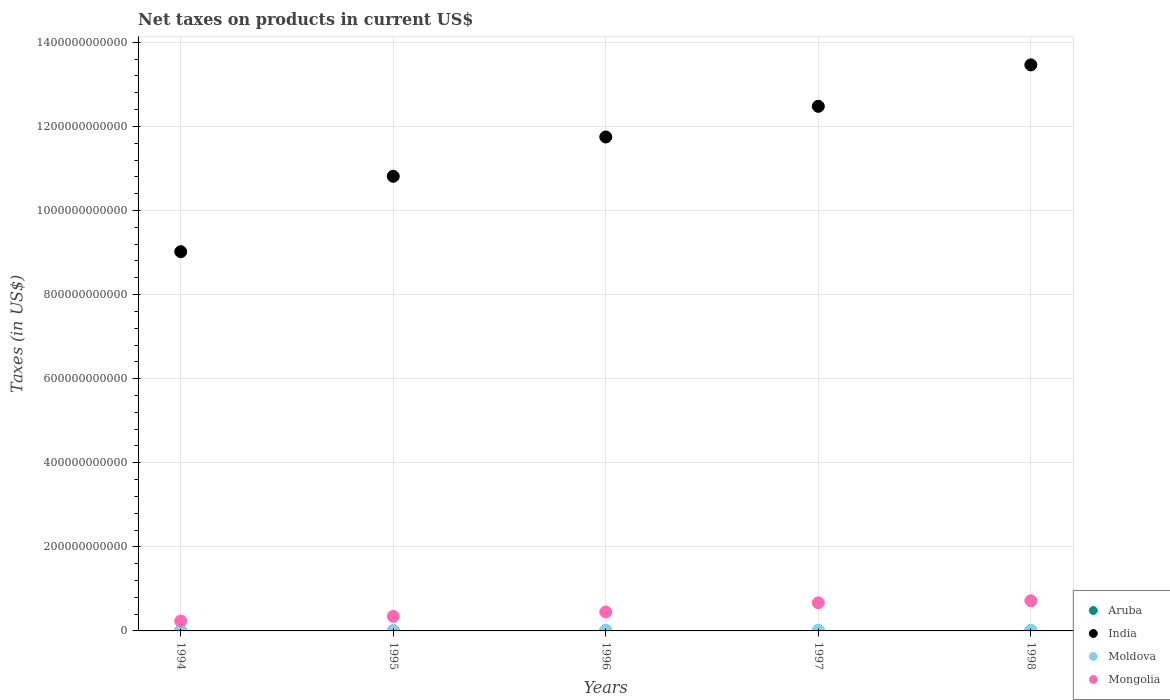How many different coloured dotlines are there?
Your answer should be compact. 4. What is the net taxes on products in Moldova in 1994?
Provide a short and direct response. 3.12e+08. Across all years, what is the maximum net taxes on products in Moldova?
Make the answer very short. 1.40e+09. Across all years, what is the minimum net taxes on products in Moldova?
Provide a short and direct response. 3.12e+08. In which year was the net taxes on products in Moldova maximum?
Provide a short and direct response. 1998. In which year was the net taxes on products in Aruba minimum?
Give a very brief answer. 1994. What is the total net taxes on products in Aruba in the graph?
Offer a very short reply. 1.09e+09. What is the difference between the net taxes on products in India in 1995 and that in 1997?
Provide a succinct answer. -1.66e+11. What is the difference between the net taxes on products in Aruba in 1998 and the net taxes on products in Mongolia in 1995?
Your response must be concise. -3.43e+1. What is the average net taxes on products in Aruba per year?
Give a very brief answer. 2.18e+08. In the year 1996, what is the difference between the net taxes on products in Moldova and net taxes on products in India?
Offer a terse response. -1.17e+12. What is the ratio of the net taxes on products in Aruba in 1996 to that in 1998?
Your answer should be very brief. 0.93. Is the net taxes on products in India in 1994 less than that in 1996?
Ensure brevity in your answer.  Yes. What is the difference between the highest and the second highest net taxes on products in Moldova?
Your answer should be compact. 1.51e+08. What is the difference between the highest and the lowest net taxes on products in Mongolia?
Offer a terse response. 4.82e+1. In how many years, is the net taxes on products in Moldova greater than the average net taxes on products in Moldova taken over all years?
Offer a very short reply. 3. Is it the case that in every year, the sum of the net taxes on products in Mongolia and net taxes on products in India  is greater than the net taxes on products in Moldova?
Provide a short and direct response. Yes. How many dotlines are there?
Give a very brief answer. 4. What is the difference between two consecutive major ticks on the Y-axis?
Ensure brevity in your answer.  2.00e+11. Where does the legend appear in the graph?
Keep it short and to the point. Bottom right. How many legend labels are there?
Keep it short and to the point. 4. What is the title of the graph?
Keep it short and to the point. Net taxes on products in current US$. What is the label or title of the Y-axis?
Keep it short and to the point. Taxes (in US$). What is the Taxes (in US$) in Aruba in 1994?
Make the answer very short. 1.95e+08. What is the Taxes (in US$) of India in 1994?
Offer a terse response. 9.02e+11. What is the Taxes (in US$) of Moldova in 1994?
Provide a short and direct response. 3.12e+08. What is the Taxes (in US$) of Mongolia in 1994?
Your answer should be very brief. 2.35e+1. What is the Taxes (in US$) of Aruba in 1995?
Offer a very short reply. 2.09e+08. What is the Taxes (in US$) of India in 1995?
Give a very brief answer. 1.08e+12. What is the Taxes (in US$) in Moldova in 1995?
Offer a very short reply. 7.36e+08. What is the Taxes (in US$) in Mongolia in 1995?
Keep it short and to the point. 3.45e+1. What is the Taxes (in US$) of Aruba in 1996?
Keep it short and to the point. 2.21e+08. What is the Taxes (in US$) of India in 1996?
Your response must be concise. 1.17e+12. What is the Taxes (in US$) of Moldova in 1996?
Your answer should be compact. 9.72e+08. What is the Taxes (in US$) in Mongolia in 1996?
Provide a succinct answer. 4.51e+1. What is the Taxes (in US$) of Aruba in 1997?
Make the answer very short. 2.29e+08. What is the Taxes (in US$) in India in 1997?
Provide a succinct answer. 1.25e+12. What is the Taxes (in US$) in Moldova in 1997?
Provide a succinct answer. 1.25e+09. What is the Taxes (in US$) in Mongolia in 1997?
Make the answer very short. 6.69e+1. What is the Taxes (in US$) in Aruba in 1998?
Your response must be concise. 2.38e+08. What is the Taxes (in US$) of India in 1998?
Your answer should be very brief. 1.35e+12. What is the Taxes (in US$) in Moldova in 1998?
Offer a very short reply. 1.40e+09. What is the Taxes (in US$) in Mongolia in 1998?
Provide a short and direct response. 7.17e+1. Across all years, what is the maximum Taxes (in US$) in Aruba?
Your response must be concise. 2.38e+08. Across all years, what is the maximum Taxes (in US$) of India?
Give a very brief answer. 1.35e+12. Across all years, what is the maximum Taxes (in US$) in Moldova?
Offer a very short reply. 1.40e+09. Across all years, what is the maximum Taxes (in US$) of Mongolia?
Make the answer very short. 7.17e+1. Across all years, what is the minimum Taxes (in US$) of Aruba?
Make the answer very short. 1.95e+08. Across all years, what is the minimum Taxes (in US$) of India?
Give a very brief answer. 9.02e+11. Across all years, what is the minimum Taxes (in US$) of Moldova?
Give a very brief answer. 3.12e+08. Across all years, what is the minimum Taxes (in US$) of Mongolia?
Offer a terse response. 2.35e+1. What is the total Taxes (in US$) in Aruba in the graph?
Ensure brevity in your answer.  1.09e+09. What is the total Taxes (in US$) of India in the graph?
Provide a short and direct response. 5.75e+12. What is the total Taxes (in US$) in Moldova in the graph?
Ensure brevity in your answer.  4.67e+09. What is the total Taxes (in US$) in Mongolia in the graph?
Provide a succinct answer. 2.42e+11. What is the difference between the Taxes (in US$) of Aruba in 1994 and that in 1995?
Give a very brief answer. -1.40e+07. What is the difference between the Taxes (in US$) in India in 1994 and that in 1995?
Your response must be concise. -1.79e+11. What is the difference between the Taxes (in US$) of Moldova in 1994 and that in 1995?
Offer a very short reply. -4.24e+08. What is the difference between the Taxes (in US$) of Mongolia in 1994 and that in 1995?
Your answer should be compact. -1.10e+1. What is the difference between the Taxes (in US$) of Aruba in 1994 and that in 1996?
Offer a very short reply. -2.60e+07. What is the difference between the Taxes (in US$) in India in 1994 and that in 1996?
Provide a short and direct response. -2.73e+11. What is the difference between the Taxes (in US$) in Moldova in 1994 and that in 1996?
Make the answer very short. -6.60e+08. What is the difference between the Taxes (in US$) in Mongolia in 1994 and that in 1996?
Your answer should be compact. -2.16e+1. What is the difference between the Taxes (in US$) of Aruba in 1994 and that in 1997?
Give a very brief answer. -3.40e+07. What is the difference between the Taxes (in US$) of India in 1994 and that in 1997?
Give a very brief answer. -3.46e+11. What is the difference between the Taxes (in US$) in Moldova in 1994 and that in 1997?
Keep it short and to the point. -9.41e+08. What is the difference between the Taxes (in US$) in Mongolia in 1994 and that in 1997?
Your response must be concise. -4.34e+1. What is the difference between the Taxes (in US$) in Aruba in 1994 and that in 1998?
Offer a terse response. -4.35e+07. What is the difference between the Taxes (in US$) of India in 1994 and that in 1998?
Your answer should be compact. -4.44e+11. What is the difference between the Taxes (in US$) of Moldova in 1994 and that in 1998?
Offer a terse response. -1.09e+09. What is the difference between the Taxes (in US$) of Mongolia in 1994 and that in 1998?
Your answer should be very brief. -4.82e+1. What is the difference between the Taxes (in US$) of Aruba in 1995 and that in 1996?
Offer a very short reply. -1.20e+07. What is the difference between the Taxes (in US$) of India in 1995 and that in 1996?
Ensure brevity in your answer.  -9.35e+1. What is the difference between the Taxes (in US$) in Moldova in 1995 and that in 1996?
Give a very brief answer. -2.36e+08. What is the difference between the Taxes (in US$) in Mongolia in 1995 and that in 1996?
Give a very brief answer. -1.06e+1. What is the difference between the Taxes (in US$) in Aruba in 1995 and that in 1997?
Offer a terse response. -2.00e+07. What is the difference between the Taxes (in US$) in India in 1995 and that in 1997?
Your answer should be very brief. -1.66e+11. What is the difference between the Taxes (in US$) in Moldova in 1995 and that in 1997?
Your answer should be compact. -5.17e+08. What is the difference between the Taxes (in US$) in Mongolia in 1995 and that in 1997?
Give a very brief answer. -3.24e+1. What is the difference between the Taxes (in US$) in Aruba in 1995 and that in 1998?
Give a very brief answer. -2.95e+07. What is the difference between the Taxes (in US$) in India in 1995 and that in 1998?
Give a very brief answer. -2.65e+11. What is the difference between the Taxes (in US$) of Moldova in 1995 and that in 1998?
Your answer should be compact. -6.68e+08. What is the difference between the Taxes (in US$) in Mongolia in 1995 and that in 1998?
Keep it short and to the point. -3.72e+1. What is the difference between the Taxes (in US$) of Aruba in 1996 and that in 1997?
Give a very brief answer. -8.00e+06. What is the difference between the Taxes (in US$) of India in 1996 and that in 1997?
Ensure brevity in your answer.  -7.29e+1. What is the difference between the Taxes (in US$) of Moldova in 1996 and that in 1997?
Make the answer very short. -2.81e+08. What is the difference between the Taxes (in US$) in Mongolia in 1996 and that in 1997?
Offer a very short reply. -2.18e+1. What is the difference between the Taxes (in US$) of Aruba in 1996 and that in 1998?
Your answer should be compact. -1.75e+07. What is the difference between the Taxes (in US$) of India in 1996 and that in 1998?
Provide a short and direct response. -1.72e+11. What is the difference between the Taxes (in US$) of Moldova in 1996 and that in 1998?
Keep it short and to the point. -4.32e+08. What is the difference between the Taxes (in US$) of Mongolia in 1996 and that in 1998?
Your answer should be very brief. -2.66e+1. What is the difference between the Taxes (in US$) of Aruba in 1997 and that in 1998?
Give a very brief answer. -9.46e+06. What is the difference between the Taxes (in US$) of India in 1997 and that in 1998?
Keep it short and to the point. -9.86e+1. What is the difference between the Taxes (in US$) in Moldova in 1997 and that in 1998?
Make the answer very short. -1.51e+08. What is the difference between the Taxes (in US$) in Mongolia in 1997 and that in 1998?
Keep it short and to the point. -4.81e+09. What is the difference between the Taxes (in US$) in Aruba in 1994 and the Taxes (in US$) in India in 1995?
Give a very brief answer. -1.08e+12. What is the difference between the Taxes (in US$) of Aruba in 1994 and the Taxes (in US$) of Moldova in 1995?
Keep it short and to the point. -5.41e+08. What is the difference between the Taxes (in US$) in Aruba in 1994 and the Taxes (in US$) in Mongolia in 1995?
Your answer should be compact. -3.43e+1. What is the difference between the Taxes (in US$) of India in 1994 and the Taxes (in US$) of Moldova in 1995?
Make the answer very short. 9.01e+11. What is the difference between the Taxes (in US$) of India in 1994 and the Taxes (in US$) of Mongolia in 1995?
Your answer should be compact. 8.68e+11. What is the difference between the Taxes (in US$) in Moldova in 1994 and the Taxes (in US$) in Mongolia in 1995?
Give a very brief answer. -3.42e+1. What is the difference between the Taxes (in US$) of Aruba in 1994 and the Taxes (in US$) of India in 1996?
Your response must be concise. -1.17e+12. What is the difference between the Taxes (in US$) of Aruba in 1994 and the Taxes (in US$) of Moldova in 1996?
Give a very brief answer. -7.77e+08. What is the difference between the Taxes (in US$) of Aruba in 1994 and the Taxes (in US$) of Mongolia in 1996?
Provide a succinct answer. -4.49e+1. What is the difference between the Taxes (in US$) of India in 1994 and the Taxes (in US$) of Moldova in 1996?
Offer a terse response. 9.01e+11. What is the difference between the Taxes (in US$) in India in 1994 and the Taxes (in US$) in Mongolia in 1996?
Give a very brief answer. 8.57e+11. What is the difference between the Taxes (in US$) of Moldova in 1994 and the Taxes (in US$) of Mongolia in 1996?
Your answer should be very brief. -4.48e+1. What is the difference between the Taxes (in US$) of Aruba in 1994 and the Taxes (in US$) of India in 1997?
Ensure brevity in your answer.  -1.25e+12. What is the difference between the Taxes (in US$) in Aruba in 1994 and the Taxes (in US$) in Moldova in 1997?
Keep it short and to the point. -1.06e+09. What is the difference between the Taxes (in US$) in Aruba in 1994 and the Taxes (in US$) in Mongolia in 1997?
Give a very brief answer. -6.67e+1. What is the difference between the Taxes (in US$) of India in 1994 and the Taxes (in US$) of Moldova in 1997?
Ensure brevity in your answer.  9.01e+11. What is the difference between the Taxes (in US$) of India in 1994 and the Taxes (in US$) of Mongolia in 1997?
Make the answer very short. 8.35e+11. What is the difference between the Taxes (in US$) in Moldova in 1994 and the Taxes (in US$) in Mongolia in 1997?
Give a very brief answer. -6.66e+1. What is the difference between the Taxes (in US$) in Aruba in 1994 and the Taxes (in US$) in India in 1998?
Ensure brevity in your answer.  -1.35e+12. What is the difference between the Taxes (in US$) of Aruba in 1994 and the Taxes (in US$) of Moldova in 1998?
Give a very brief answer. -1.21e+09. What is the difference between the Taxes (in US$) in Aruba in 1994 and the Taxes (in US$) in Mongolia in 1998?
Provide a succinct answer. -7.15e+1. What is the difference between the Taxes (in US$) in India in 1994 and the Taxes (in US$) in Moldova in 1998?
Your answer should be very brief. 9.01e+11. What is the difference between the Taxes (in US$) of India in 1994 and the Taxes (in US$) of Mongolia in 1998?
Keep it short and to the point. 8.30e+11. What is the difference between the Taxes (in US$) in Moldova in 1994 and the Taxes (in US$) in Mongolia in 1998?
Ensure brevity in your answer.  -7.14e+1. What is the difference between the Taxes (in US$) of Aruba in 1995 and the Taxes (in US$) of India in 1996?
Give a very brief answer. -1.17e+12. What is the difference between the Taxes (in US$) of Aruba in 1995 and the Taxes (in US$) of Moldova in 1996?
Offer a very short reply. -7.63e+08. What is the difference between the Taxes (in US$) in Aruba in 1995 and the Taxes (in US$) in Mongolia in 1996?
Your answer should be compact. -4.49e+1. What is the difference between the Taxes (in US$) of India in 1995 and the Taxes (in US$) of Moldova in 1996?
Your response must be concise. 1.08e+12. What is the difference between the Taxes (in US$) in India in 1995 and the Taxes (in US$) in Mongolia in 1996?
Offer a terse response. 1.04e+12. What is the difference between the Taxes (in US$) in Moldova in 1995 and the Taxes (in US$) in Mongolia in 1996?
Provide a succinct answer. -4.44e+1. What is the difference between the Taxes (in US$) in Aruba in 1995 and the Taxes (in US$) in India in 1997?
Ensure brevity in your answer.  -1.25e+12. What is the difference between the Taxes (in US$) of Aruba in 1995 and the Taxes (in US$) of Moldova in 1997?
Offer a terse response. -1.04e+09. What is the difference between the Taxes (in US$) in Aruba in 1995 and the Taxes (in US$) in Mongolia in 1997?
Offer a very short reply. -6.67e+1. What is the difference between the Taxes (in US$) in India in 1995 and the Taxes (in US$) in Moldova in 1997?
Ensure brevity in your answer.  1.08e+12. What is the difference between the Taxes (in US$) in India in 1995 and the Taxes (in US$) in Mongolia in 1997?
Make the answer very short. 1.01e+12. What is the difference between the Taxes (in US$) of Moldova in 1995 and the Taxes (in US$) of Mongolia in 1997?
Keep it short and to the point. -6.62e+1. What is the difference between the Taxes (in US$) of Aruba in 1995 and the Taxes (in US$) of India in 1998?
Offer a very short reply. -1.35e+12. What is the difference between the Taxes (in US$) in Aruba in 1995 and the Taxes (in US$) in Moldova in 1998?
Offer a terse response. -1.19e+09. What is the difference between the Taxes (in US$) in Aruba in 1995 and the Taxes (in US$) in Mongolia in 1998?
Your answer should be compact. -7.15e+1. What is the difference between the Taxes (in US$) of India in 1995 and the Taxes (in US$) of Moldova in 1998?
Give a very brief answer. 1.08e+12. What is the difference between the Taxes (in US$) of India in 1995 and the Taxes (in US$) of Mongolia in 1998?
Offer a very short reply. 1.01e+12. What is the difference between the Taxes (in US$) in Moldova in 1995 and the Taxes (in US$) in Mongolia in 1998?
Your answer should be compact. -7.10e+1. What is the difference between the Taxes (in US$) in Aruba in 1996 and the Taxes (in US$) in India in 1997?
Your answer should be compact. -1.25e+12. What is the difference between the Taxes (in US$) in Aruba in 1996 and the Taxes (in US$) in Moldova in 1997?
Your answer should be very brief. -1.03e+09. What is the difference between the Taxes (in US$) in Aruba in 1996 and the Taxes (in US$) in Mongolia in 1997?
Provide a short and direct response. -6.67e+1. What is the difference between the Taxes (in US$) in India in 1996 and the Taxes (in US$) in Moldova in 1997?
Offer a very short reply. 1.17e+12. What is the difference between the Taxes (in US$) in India in 1996 and the Taxes (in US$) in Mongolia in 1997?
Ensure brevity in your answer.  1.11e+12. What is the difference between the Taxes (in US$) of Moldova in 1996 and the Taxes (in US$) of Mongolia in 1997?
Give a very brief answer. -6.59e+1. What is the difference between the Taxes (in US$) of Aruba in 1996 and the Taxes (in US$) of India in 1998?
Provide a succinct answer. -1.35e+12. What is the difference between the Taxes (in US$) of Aruba in 1996 and the Taxes (in US$) of Moldova in 1998?
Make the answer very short. -1.18e+09. What is the difference between the Taxes (in US$) in Aruba in 1996 and the Taxes (in US$) in Mongolia in 1998?
Ensure brevity in your answer.  -7.15e+1. What is the difference between the Taxes (in US$) of India in 1996 and the Taxes (in US$) of Moldova in 1998?
Ensure brevity in your answer.  1.17e+12. What is the difference between the Taxes (in US$) of India in 1996 and the Taxes (in US$) of Mongolia in 1998?
Offer a very short reply. 1.10e+12. What is the difference between the Taxes (in US$) in Moldova in 1996 and the Taxes (in US$) in Mongolia in 1998?
Provide a short and direct response. -7.07e+1. What is the difference between the Taxes (in US$) of Aruba in 1997 and the Taxes (in US$) of India in 1998?
Your answer should be very brief. -1.35e+12. What is the difference between the Taxes (in US$) of Aruba in 1997 and the Taxes (in US$) of Moldova in 1998?
Your answer should be very brief. -1.17e+09. What is the difference between the Taxes (in US$) of Aruba in 1997 and the Taxes (in US$) of Mongolia in 1998?
Your answer should be compact. -7.15e+1. What is the difference between the Taxes (in US$) in India in 1997 and the Taxes (in US$) in Moldova in 1998?
Make the answer very short. 1.25e+12. What is the difference between the Taxes (in US$) of India in 1997 and the Taxes (in US$) of Mongolia in 1998?
Give a very brief answer. 1.18e+12. What is the difference between the Taxes (in US$) in Moldova in 1997 and the Taxes (in US$) in Mongolia in 1998?
Offer a terse response. -7.04e+1. What is the average Taxes (in US$) in Aruba per year?
Offer a terse response. 2.18e+08. What is the average Taxes (in US$) of India per year?
Your answer should be compact. 1.15e+12. What is the average Taxes (in US$) of Moldova per year?
Offer a terse response. 9.35e+08. What is the average Taxes (in US$) in Mongolia per year?
Your response must be concise. 4.84e+1. In the year 1994, what is the difference between the Taxes (in US$) of Aruba and Taxes (in US$) of India?
Offer a very short reply. -9.02e+11. In the year 1994, what is the difference between the Taxes (in US$) in Aruba and Taxes (in US$) in Moldova?
Your answer should be compact. -1.17e+08. In the year 1994, what is the difference between the Taxes (in US$) of Aruba and Taxes (in US$) of Mongolia?
Make the answer very short. -2.33e+1. In the year 1994, what is the difference between the Taxes (in US$) of India and Taxes (in US$) of Moldova?
Your answer should be very brief. 9.02e+11. In the year 1994, what is the difference between the Taxes (in US$) in India and Taxes (in US$) in Mongolia?
Your answer should be very brief. 8.79e+11. In the year 1994, what is the difference between the Taxes (in US$) of Moldova and Taxes (in US$) of Mongolia?
Provide a short and direct response. -2.32e+1. In the year 1995, what is the difference between the Taxes (in US$) in Aruba and Taxes (in US$) in India?
Keep it short and to the point. -1.08e+12. In the year 1995, what is the difference between the Taxes (in US$) in Aruba and Taxes (in US$) in Moldova?
Make the answer very short. -5.27e+08. In the year 1995, what is the difference between the Taxes (in US$) in Aruba and Taxes (in US$) in Mongolia?
Give a very brief answer. -3.43e+1. In the year 1995, what is the difference between the Taxes (in US$) in India and Taxes (in US$) in Moldova?
Ensure brevity in your answer.  1.08e+12. In the year 1995, what is the difference between the Taxes (in US$) in India and Taxes (in US$) in Mongolia?
Provide a short and direct response. 1.05e+12. In the year 1995, what is the difference between the Taxes (in US$) of Moldova and Taxes (in US$) of Mongolia?
Ensure brevity in your answer.  -3.38e+1. In the year 1996, what is the difference between the Taxes (in US$) of Aruba and Taxes (in US$) of India?
Give a very brief answer. -1.17e+12. In the year 1996, what is the difference between the Taxes (in US$) in Aruba and Taxes (in US$) in Moldova?
Ensure brevity in your answer.  -7.51e+08. In the year 1996, what is the difference between the Taxes (in US$) of Aruba and Taxes (in US$) of Mongolia?
Provide a succinct answer. -4.49e+1. In the year 1996, what is the difference between the Taxes (in US$) in India and Taxes (in US$) in Moldova?
Provide a succinct answer. 1.17e+12. In the year 1996, what is the difference between the Taxes (in US$) of India and Taxes (in US$) of Mongolia?
Ensure brevity in your answer.  1.13e+12. In the year 1996, what is the difference between the Taxes (in US$) in Moldova and Taxes (in US$) in Mongolia?
Offer a very short reply. -4.42e+1. In the year 1997, what is the difference between the Taxes (in US$) in Aruba and Taxes (in US$) in India?
Give a very brief answer. -1.25e+12. In the year 1997, what is the difference between the Taxes (in US$) of Aruba and Taxes (in US$) of Moldova?
Your response must be concise. -1.02e+09. In the year 1997, what is the difference between the Taxes (in US$) of Aruba and Taxes (in US$) of Mongolia?
Keep it short and to the point. -6.67e+1. In the year 1997, what is the difference between the Taxes (in US$) of India and Taxes (in US$) of Moldova?
Your answer should be very brief. 1.25e+12. In the year 1997, what is the difference between the Taxes (in US$) in India and Taxes (in US$) in Mongolia?
Ensure brevity in your answer.  1.18e+12. In the year 1997, what is the difference between the Taxes (in US$) of Moldova and Taxes (in US$) of Mongolia?
Your answer should be very brief. -6.56e+1. In the year 1998, what is the difference between the Taxes (in US$) of Aruba and Taxes (in US$) of India?
Your answer should be very brief. -1.35e+12. In the year 1998, what is the difference between the Taxes (in US$) in Aruba and Taxes (in US$) in Moldova?
Offer a very short reply. -1.16e+09. In the year 1998, what is the difference between the Taxes (in US$) in Aruba and Taxes (in US$) in Mongolia?
Provide a succinct answer. -7.15e+1. In the year 1998, what is the difference between the Taxes (in US$) of India and Taxes (in US$) of Moldova?
Your response must be concise. 1.34e+12. In the year 1998, what is the difference between the Taxes (in US$) of India and Taxes (in US$) of Mongolia?
Provide a succinct answer. 1.27e+12. In the year 1998, what is the difference between the Taxes (in US$) in Moldova and Taxes (in US$) in Mongolia?
Your answer should be very brief. -7.03e+1. What is the ratio of the Taxes (in US$) in Aruba in 1994 to that in 1995?
Provide a succinct answer. 0.93. What is the ratio of the Taxes (in US$) of India in 1994 to that in 1995?
Your answer should be very brief. 0.83. What is the ratio of the Taxes (in US$) of Moldova in 1994 to that in 1995?
Your answer should be compact. 0.42. What is the ratio of the Taxes (in US$) in Mongolia in 1994 to that in 1995?
Keep it short and to the point. 0.68. What is the ratio of the Taxes (in US$) in Aruba in 1994 to that in 1996?
Your answer should be very brief. 0.88. What is the ratio of the Taxes (in US$) of India in 1994 to that in 1996?
Provide a short and direct response. 0.77. What is the ratio of the Taxes (in US$) in Moldova in 1994 to that in 1996?
Make the answer very short. 0.32. What is the ratio of the Taxes (in US$) of Mongolia in 1994 to that in 1996?
Offer a terse response. 0.52. What is the ratio of the Taxes (in US$) of Aruba in 1994 to that in 1997?
Your answer should be compact. 0.85. What is the ratio of the Taxes (in US$) in India in 1994 to that in 1997?
Your response must be concise. 0.72. What is the ratio of the Taxes (in US$) in Moldova in 1994 to that in 1997?
Keep it short and to the point. 0.25. What is the ratio of the Taxes (in US$) in Mongolia in 1994 to that in 1997?
Ensure brevity in your answer.  0.35. What is the ratio of the Taxes (in US$) of Aruba in 1994 to that in 1998?
Your response must be concise. 0.82. What is the ratio of the Taxes (in US$) of India in 1994 to that in 1998?
Your answer should be very brief. 0.67. What is the ratio of the Taxes (in US$) of Moldova in 1994 to that in 1998?
Your response must be concise. 0.22. What is the ratio of the Taxes (in US$) of Mongolia in 1994 to that in 1998?
Offer a terse response. 0.33. What is the ratio of the Taxes (in US$) in Aruba in 1995 to that in 1996?
Provide a short and direct response. 0.95. What is the ratio of the Taxes (in US$) of India in 1995 to that in 1996?
Give a very brief answer. 0.92. What is the ratio of the Taxes (in US$) of Moldova in 1995 to that in 1996?
Provide a succinct answer. 0.76. What is the ratio of the Taxes (in US$) of Mongolia in 1995 to that in 1996?
Give a very brief answer. 0.77. What is the ratio of the Taxes (in US$) of Aruba in 1995 to that in 1997?
Provide a succinct answer. 0.91. What is the ratio of the Taxes (in US$) of India in 1995 to that in 1997?
Your response must be concise. 0.87. What is the ratio of the Taxes (in US$) of Moldova in 1995 to that in 1997?
Provide a succinct answer. 0.59. What is the ratio of the Taxes (in US$) in Mongolia in 1995 to that in 1997?
Your response must be concise. 0.52. What is the ratio of the Taxes (in US$) of Aruba in 1995 to that in 1998?
Offer a terse response. 0.88. What is the ratio of the Taxes (in US$) in India in 1995 to that in 1998?
Your answer should be compact. 0.8. What is the ratio of the Taxes (in US$) of Moldova in 1995 to that in 1998?
Your answer should be compact. 0.52. What is the ratio of the Taxes (in US$) of Mongolia in 1995 to that in 1998?
Provide a succinct answer. 0.48. What is the ratio of the Taxes (in US$) in Aruba in 1996 to that in 1997?
Give a very brief answer. 0.97. What is the ratio of the Taxes (in US$) of India in 1996 to that in 1997?
Keep it short and to the point. 0.94. What is the ratio of the Taxes (in US$) in Moldova in 1996 to that in 1997?
Ensure brevity in your answer.  0.78. What is the ratio of the Taxes (in US$) of Mongolia in 1996 to that in 1997?
Make the answer very short. 0.67. What is the ratio of the Taxes (in US$) of Aruba in 1996 to that in 1998?
Provide a short and direct response. 0.93. What is the ratio of the Taxes (in US$) in India in 1996 to that in 1998?
Your answer should be very brief. 0.87. What is the ratio of the Taxes (in US$) of Moldova in 1996 to that in 1998?
Your answer should be compact. 0.69. What is the ratio of the Taxes (in US$) of Mongolia in 1996 to that in 1998?
Provide a succinct answer. 0.63. What is the ratio of the Taxes (in US$) in Aruba in 1997 to that in 1998?
Make the answer very short. 0.96. What is the ratio of the Taxes (in US$) of India in 1997 to that in 1998?
Keep it short and to the point. 0.93. What is the ratio of the Taxes (in US$) of Moldova in 1997 to that in 1998?
Your response must be concise. 0.89. What is the ratio of the Taxes (in US$) in Mongolia in 1997 to that in 1998?
Provide a succinct answer. 0.93. What is the difference between the highest and the second highest Taxes (in US$) of Aruba?
Your answer should be very brief. 9.46e+06. What is the difference between the highest and the second highest Taxes (in US$) in India?
Provide a short and direct response. 9.86e+1. What is the difference between the highest and the second highest Taxes (in US$) of Moldova?
Offer a very short reply. 1.51e+08. What is the difference between the highest and the second highest Taxes (in US$) of Mongolia?
Provide a short and direct response. 4.81e+09. What is the difference between the highest and the lowest Taxes (in US$) of Aruba?
Provide a short and direct response. 4.35e+07. What is the difference between the highest and the lowest Taxes (in US$) of India?
Your answer should be compact. 4.44e+11. What is the difference between the highest and the lowest Taxes (in US$) in Moldova?
Give a very brief answer. 1.09e+09. What is the difference between the highest and the lowest Taxes (in US$) of Mongolia?
Ensure brevity in your answer.  4.82e+1. 